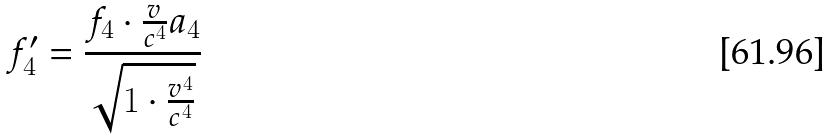<formula> <loc_0><loc_0><loc_500><loc_500>f _ { 4 } ^ { \prime } = \frac { f _ { 4 } \cdot \frac { v } { c ^ { 4 } } a _ { 4 } } { \sqrt { 1 \cdot \frac { v ^ { 4 } } { c ^ { 4 } } } }</formula> 